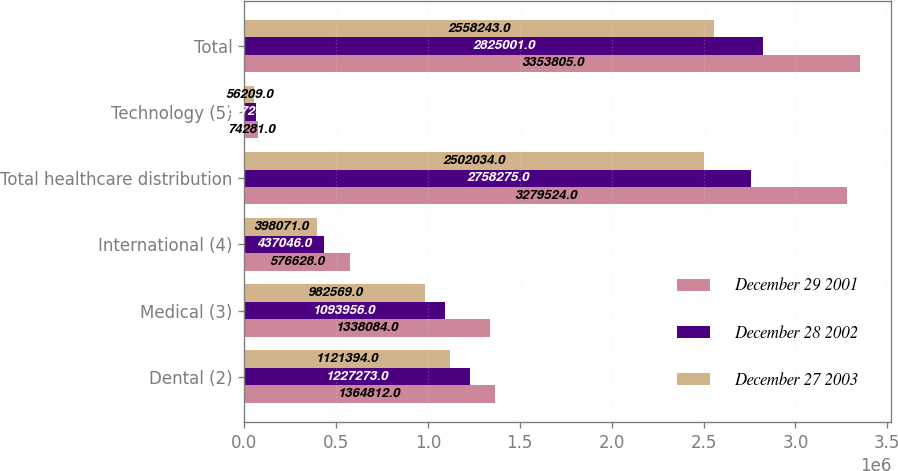<chart> <loc_0><loc_0><loc_500><loc_500><stacked_bar_chart><ecel><fcel>Dental (2)<fcel>Medical (3)<fcel>International (4)<fcel>Total healthcare distribution<fcel>Technology (5)<fcel>Total<nl><fcel>December 29 2001<fcel>1.36481e+06<fcel>1.33808e+06<fcel>576628<fcel>3.27952e+06<fcel>74281<fcel>3.3538e+06<nl><fcel>December 28 2002<fcel>1.22727e+06<fcel>1.09396e+06<fcel>437046<fcel>2.75828e+06<fcel>66726<fcel>2.825e+06<nl><fcel>December 27 2003<fcel>1.12139e+06<fcel>982569<fcel>398071<fcel>2.50203e+06<fcel>56209<fcel>2.55824e+06<nl></chart> 